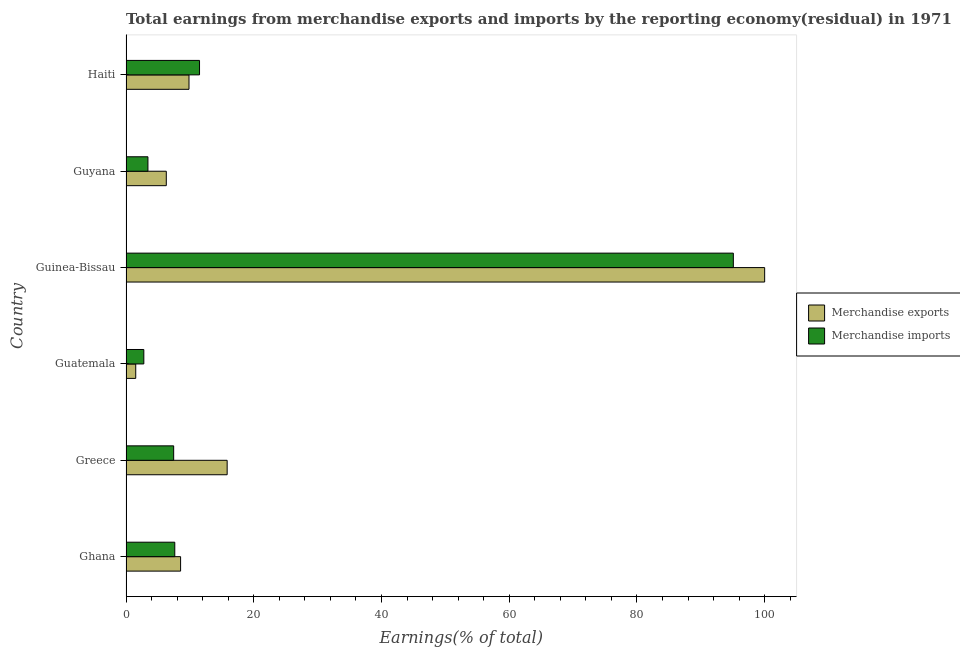How many different coloured bars are there?
Offer a very short reply. 2. How many groups of bars are there?
Make the answer very short. 6. What is the label of the 1st group of bars from the top?
Ensure brevity in your answer.  Haiti. In how many cases, is the number of bars for a given country not equal to the number of legend labels?
Provide a succinct answer. 0. What is the earnings from merchandise imports in Guyana?
Provide a succinct answer. 3.43. Across all countries, what is the maximum earnings from merchandise exports?
Your answer should be very brief. 100. Across all countries, what is the minimum earnings from merchandise exports?
Offer a terse response. 1.52. In which country was the earnings from merchandise exports maximum?
Give a very brief answer. Guinea-Bissau. In which country was the earnings from merchandise imports minimum?
Provide a short and direct response. Guatemala. What is the total earnings from merchandise imports in the graph?
Offer a very short reply. 127.93. What is the difference between the earnings from merchandise imports in Guyana and that in Haiti?
Your response must be concise. -8.08. What is the difference between the earnings from merchandise imports in Guatemala and the earnings from merchandise exports in Greece?
Make the answer very short. -13.05. What is the average earnings from merchandise imports per country?
Offer a very short reply. 21.32. What is the difference between the earnings from merchandise exports and earnings from merchandise imports in Haiti?
Keep it short and to the point. -1.65. What is the ratio of the earnings from merchandise exports in Guinea-Bissau to that in Guyana?
Offer a very short reply. 15.85. Is the difference between the earnings from merchandise exports in Guatemala and Guyana greater than the difference between the earnings from merchandise imports in Guatemala and Guyana?
Ensure brevity in your answer.  No. What is the difference between the highest and the second highest earnings from merchandise exports?
Make the answer very short. 84.16. What is the difference between the highest and the lowest earnings from merchandise imports?
Offer a terse response. 92.31. How many bars are there?
Ensure brevity in your answer.  12. How many countries are there in the graph?
Ensure brevity in your answer.  6. What is the difference between two consecutive major ticks on the X-axis?
Your response must be concise. 20. Are the values on the major ticks of X-axis written in scientific E-notation?
Make the answer very short. No. Where does the legend appear in the graph?
Your response must be concise. Center right. How are the legend labels stacked?
Provide a succinct answer. Vertical. What is the title of the graph?
Give a very brief answer. Total earnings from merchandise exports and imports by the reporting economy(residual) in 1971. Does "Lowest 20% of population" appear as one of the legend labels in the graph?
Provide a succinct answer. No. What is the label or title of the X-axis?
Ensure brevity in your answer.  Earnings(% of total). What is the Earnings(% of total) in Merchandise exports in Ghana?
Ensure brevity in your answer.  8.55. What is the Earnings(% of total) in Merchandise imports in Ghana?
Make the answer very short. 7.64. What is the Earnings(% of total) in Merchandise exports in Greece?
Provide a short and direct response. 15.84. What is the Earnings(% of total) in Merchandise imports in Greece?
Provide a succinct answer. 7.46. What is the Earnings(% of total) in Merchandise exports in Guatemala?
Offer a very short reply. 1.52. What is the Earnings(% of total) in Merchandise imports in Guatemala?
Offer a terse response. 2.79. What is the Earnings(% of total) of Merchandise imports in Guinea-Bissau?
Your answer should be compact. 95.1. What is the Earnings(% of total) in Merchandise exports in Guyana?
Keep it short and to the point. 6.31. What is the Earnings(% of total) in Merchandise imports in Guyana?
Your response must be concise. 3.43. What is the Earnings(% of total) in Merchandise exports in Haiti?
Give a very brief answer. 9.86. What is the Earnings(% of total) in Merchandise imports in Haiti?
Offer a very short reply. 11.51. Across all countries, what is the maximum Earnings(% of total) of Merchandise imports?
Make the answer very short. 95.1. Across all countries, what is the minimum Earnings(% of total) of Merchandise exports?
Provide a short and direct response. 1.52. Across all countries, what is the minimum Earnings(% of total) in Merchandise imports?
Make the answer very short. 2.79. What is the total Earnings(% of total) of Merchandise exports in the graph?
Provide a short and direct response. 142.08. What is the total Earnings(% of total) of Merchandise imports in the graph?
Offer a very short reply. 127.93. What is the difference between the Earnings(% of total) of Merchandise exports in Ghana and that in Greece?
Your response must be concise. -7.29. What is the difference between the Earnings(% of total) in Merchandise imports in Ghana and that in Greece?
Provide a succinct answer. 0.17. What is the difference between the Earnings(% of total) in Merchandise exports in Ghana and that in Guatemala?
Your answer should be compact. 7.02. What is the difference between the Earnings(% of total) of Merchandise imports in Ghana and that in Guatemala?
Give a very brief answer. 4.85. What is the difference between the Earnings(% of total) in Merchandise exports in Ghana and that in Guinea-Bissau?
Ensure brevity in your answer.  -91.45. What is the difference between the Earnings(% of total) in Merchandise imports in Ghana and that in Guinea-Bissau?
Your response must be concise. -87.46. What is the difference between the Earnings(% of total) in Merchandise exports in Ghana and that in Guyana?
Offer a very short reply. 2.24. What is the difference between the Earnings(% of total) of Merchandise imports in Ghana and that in Guyana?
Make the answer very short. 4.2. What is the difference between the Earnings(% of total) of Merchandise exports in Ghana and that in Haiti?
Your response must be concise. -1.32. What is the difference between the Earnings(% of total) of Merchandise imports in Ghana and that in Haiti?
Make the answer very short. -3.87. What is the difference between the Earnings(% of total) in Merchandise exports in Greece and that in Guatemala?
Your answer should be compact. 14.31. What is the difference between the Earnings(% of total) of Merchandise imports in Greece and that in Guatemala?
Keep it short and to the point. 4.67. What is the difference between the Earnings(% of total) of Merchandise exports in Greece and that in Guinea-Bissau?
Your answer should be compact. -84.16. What is the difference between the Earnings(% of total) of Merchandise imports in Greece and that in Guinea-Bissau?
Offer a very short reply. -87.63. What is the difference between the Earnings(% of total) in Merchandise exports in Greece and that in Guyana?
Your answer should be very brief. 9.53. What is the difference between the Earnings(% of total) in Merchandise imports in Greece and that in Guyana?
Give a very brief answer. 4.03. What is the difference between the Earnings(% of total) in Merchandise exports in Greece and that in Haiti?
Provide a succinct answer. 5.97. What is the difference between the Earnings(% of total) in Merchandise imports in Greece and that in Haiti?
Your answer should be compact. -4.05. What is the difference between the Earnings(% of total) in Merchandise exports in Guatemala and that in Guinea-Bissau?
Your answer should be compact. -98.48. What is the difference between the Earnings(% of total) of Merchandise imports in Guatemala and that in Guinea-Bissau?
Offer a terse response. -92.31. What is the difference between the Earnings(% of total) in Merchandise exports in Guatemala and that in Guyana?
Your response must be concise. -4.79. What is the difference between the Earnings(% of total) of Merchandise imports in Guatemala and that in Guyana?
Your answer should be very brief. -0.64. What is the difference between the Earnings(% of total) in Merchandise exports in Guatemala and that in Haiti?
Provide a short and direct response. -8.34. What is the difference between the Earnings(% of total) in Merchandise imports in Guatemala and that in Haiti?
Your answer should be very brief. -8.72. What is the difference between the Earnings(% of total) in Merchandise exports in Guinea-Bissau and that in Guyana?
Your response must be concise. 93.69. What is the difference between the Earnings(% of total) of Merchandise imports in Guinea-Bissau and that in Guyana?
Your answer should be very brief. 91.67. What is the difference between the Earnings(% of total) of Merchandise exports in Guinea-Bissau and that in Haiti?
Offer a very short reply. 90.14. What is the difference between the Earnings(% of total) of Merchandise imports in Guinea-Bissau and that in Haiti?
Your response must be concise. 83.59. What is the difference between the Earnings(% of total) of Merchandise exports in Guyana and that in Haiti?
Your answer should be very brief. -3.55. What is the difference between the Earnings(% of total) in Merchandise imports in Guyana and that in Haiti?
Provide a succinct answer. -8.08. What is the difference between the Earnings(% of total) of Merchandise exports in Ghana and the Earnings(% of total) of Merchandise imports in Greece?
Provide a short and direct response. 1.08. What is the difference between the Earnings(% of total) of Merchandise exports in Ghana and the Earnings(% of total) of Merchandise imports in Guatemala?
Give a very brief answer. 5.76. What is the difference between the Earnings(% of total) in Merchandise exports in Ghana and the Earnings(% of total) in Merchandise imports in Guinea-Bissau?
Make the answer very short. -86.55. What is the difference between the Earnings(% of total) in Merchandise exports in Ghana and the Earnings(% of total) in Merchandise imports in Guyana?
Give a very brief answer. 5.11. What is the difference between the Earnings(% of total) in Merchandise exports in Ghana and the Earnings(% of total) in Merchandise imports in Haiti?
Keep it short and to the point. -2.96. What is the difference between the Earnings(% of total) of Merchandise exports in Greece and the Earnings(% of total) of Merchandise imports in Guatemala?
Make the answer very short. 13.05. What is the difference between the Earnings(% of total) of Merchandise exports in Greece and the Earnings(% of total) of Merchandise imports in Guinea-Bissau?
Your answer should be compact. -79.26. What is the difference between the Earnings(% of total) in Merchandise exports in Greece and the Earnings(% of total) in Merchandise imports in Guyana?
Your answer should be very brief. 12.4. What is the difference between the Earnings(% of total) of Merchandise exports in Greece and the Earnings(% of total) of Merchandise imports in Haiti?
Your answer should be very brief. 4.33. What is the difference between the Earnings(% of total) of Merchandise exports in Guatemala and the Earnings(% of total) of Merchandise imports in Guinea-Bissau?
Provide a short and direct response. -93.58. What is the difference between the Earnings(% of total) of Merchandise exports in Guatemala and the Earnings(% of total) of Merchandise imports in Guyana?
Ensure brevity in your answer.  -1.91. What is the difference between the Earnings(% of total) of Merchandise exports in Guatemala and the Earnings(% of total) of Merchandise imports in Haiti?
Provide a succinct answer. -9.99. What is the difference between the Earnings(% of total) in Merchandise exports in Guinea-Bissau and the Earnings(% of total) in Merchandise imports in Guyana?
Offer a terse response. 96.57. What is the difference between the Earnings(% of total) of Merchandise exports in Guinea-Bissau and the Earnings(% of total) of Merchandise imports in Haiti?
Provide a short and direct response. 88.49. What is the difference between the Earnings(% of total) in Merchandise exports in Guyana and the Earnings(% of total) in Merchandise imports in Haiti?
Provide a succinct answer. -5.2. What is the average Earnings(% of total) in Merchandise exports per country?
Offer a very short reply. 23.68. What is the average Earnings(% of total) of Merchandise imports per country?
Your answer should be compact. 21.32. What is the difference between the Earnings(% of total) of Merchandise exports and Earnings(% of total) of Merchandise imports in Ghana?
Provide a short and direct response. 0.91. What is the difference between the Earnings(% of total) of Merchandise exports and Earnings(% of total) of Merchandise imports in Greece?
Offer a terse response. 8.37. What is the difference between the Earnings(% of total) in Merchandise exports and Earnings(% of total) in Merchandise imports in Guatemala?
Offer a terse response. -1.27. What is the difference between the Earnings(% of total) of Merchandise exports and Earnings(% of total) of Merchandise imports in Guinea-Bissau?
Provide a short and direct response. 4.9. What is the difference between the Earnings(% of total) in Merchandise exports and Earnings(% of total) in Merchandise imports in Guyana?
Ensure brevity in your answer.  2.88. What is the difference between the Earnings(% of total) in Merchandise exports and Earnings(% of total) in Merchandise imports in Haiti?
Ensure brevity in your answer.  -1.65. What is the ratio of the Earnings(% of total) in Merchandise exports in Ghana to that in Greece?
Offer a very short reply. 0.54. What is the ratio of the Earnings(% of total) in Merchandise imports in Ghana to that in Greece?
Keep it short and to the point. 1.02. What is the ratio of the Earnings(% of total) in Merchandise exports in Ghana to that in Guatemala?
Offer a terse response. 5.62. What is the ratio of the Earnings(% of total) of Merchandise imports in Ghana to that in Guatemala?
Provide a succinct answer. 2.74. What is the ratio of the Earnings(% of total) of Merchandise exports in Ghana to that in Guinea-Bissau?
Provide a short and direct response. 0.09. What is the ratio of the Earnings(% of total) in Merchandise imports in Ghana to that in Guinea-Bissau?
Provide a succinct answer. 0.08. What is the ratio of the Earnings(% of total) in Merchandise exports in Ghana to that in Guyana?
Ensure brevity in your answer.  1.35. What is the ratio of the Earnings(% of total) in Merchandise imports in Ghana to that in Guyana?
Ensure brevity in your answer.  2.23. What is the ratio of the Earnings(% of total) of Merchandise exports in Ghana to that in Haiti?
Offer a terse response. 0.87. What is the ratio of the Earnings(% of total) in Merchandise imports in Ghana to that in Haiti?
Provide a short and direct response. 0.66. What is the ratio of the Earnings(% of total) of Merchandise exports in Greece to that in Guatemala?
Ensure brevity in your answer.  10.4. What is the ratio of the Earnings(% of total) of Merchandise imports in Greece to that in Guatemala?
Provide a succinct answer. 2.68. What is the ratio of the Earnings(% of total) of Merchandise exports in Greece to that in Guinea-Bissau?
Your answer should be very brief. 0.16. What is the ratio of the Earnings(% of total) of Merchandise imports in Greece to that in Guinea-Bissau?
Make the answer very short. 0.08. What is the ratio of the Earnings(% of total) of Merchandise exports in Greece to that in Guyana?
Your answer should be compact. 2.51. What is the ratio of the Earnings(% of total) of Merchandise imports in Greece to that in Guyana?
Your response must be concise. 2.17. What is the ratio of the Earnings(% of total) of Merchandise exports in Greece to that in Haiti?
Ensure brevity in your answer.  1.61. What is the ratio of the Earnings(% of total) of Merchandise imports in Greece to that in Haiti?
Provide a short and direct response. 0.65. What is the ratio of the Earnings(% of total) of Merchandise exports in Guatemala to that in Guinea-Bissau?
Your response must be concise. 0.02. What is the ratio of the Earnings(% of total) of Merchandise imports in Guatemala to that in Guinea-Bissau?
Offer a very short reply. 0.03. What is the ratio of the Earnings(% of total) in Merchandise exports in Guatemala to that in Guyana?
Ensure brevity in your answer.  0.24. What is the ratio of the Earnings(% of total) of Merchandise imports in Guatemala to that in Guyana?
Your answer should be compact. 0.81. What is the ratio of the Earnings(% of total) of Merchandise exports in Guatemala to that in Haiti?
Keep it short and to the point. 0.15. What is the ratio of the Earnings(% of total) of Merchandise imports in Guatemala to that in Haiti?
Provide a short and direct response. 0.24. What is the ratio of the Earnings(% of total) of Merchandise exports in Guinea-Bissau to that in Guyana?
Offer a very short reply. 15.85. What is the ratio of the Earnings(% of total) of Merchandise imports in Guinea-Bissau to that in Guyana?
Your response must be concise. 27.7. What is the ratio of the Earnings(% of total) of Merchandise exports in Guinea-Bissau to that in Haiti?
Provide a succinct answer. 10.14. What is the ratio of the Earnings(% of total) in Merchandise imports in Guinea-Bissau to that in Haiti?
Offer a terse response. 8.26. What is the ratio of the Earnings(% of total) of Merchandise exports in Guyana to that in Haiti?
Give a very brief answer. 0.64. What is the ratio of the Earnings(% of total) of Merchandise imports in Guyana to that in Haiti?
Make the answer very short. 0.3. What is the difference between the highest and the second highest Earnings(% of total) in Merchandise exports?
Your response must be concise. 84.16. What is the difference between the highest and the second highest Earnings(% of total) of Merchandise imports?
Ensure brevity in your answer.  83.59. What is the difference between the highest and the lowest Earnings(% of total) in Merchandise exports?
Offer a terse response. 98.48. What is the difference between the highest and the lowest Earnings(% of total) in Merchandise imports?
Offer a terse response. 92.31. 